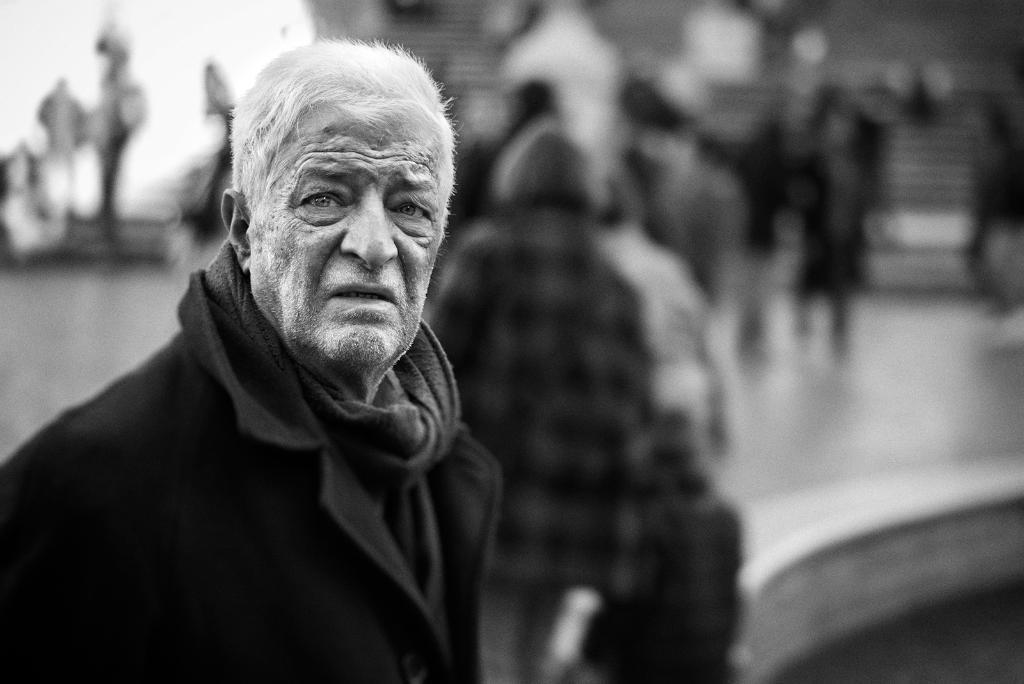How would you summarize this image in a sentence or two? This is a black and white image. In this image, on the left side, we can see a man wearing a black color dress. In the background, we can see a group of people. 